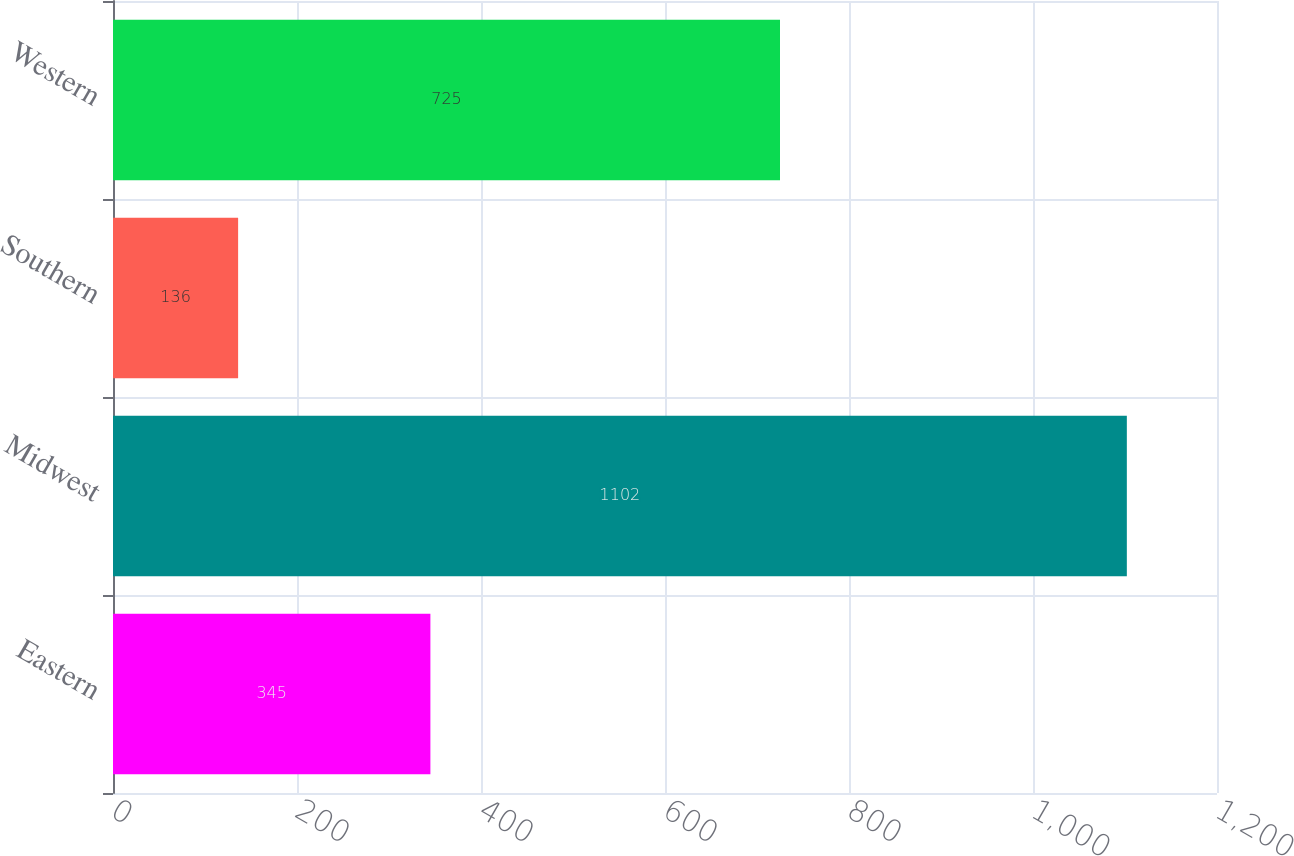Convert chart to OTSL. <chart><loc_0><loc_0><loc_500><loc_500><bar_chart><fcel>Eastern<fcel>Midwest<fcel>Southern<fcel>Western<nl><fcel>345<fcel>1102<fcel>136<fcel>725<nl></chart> 